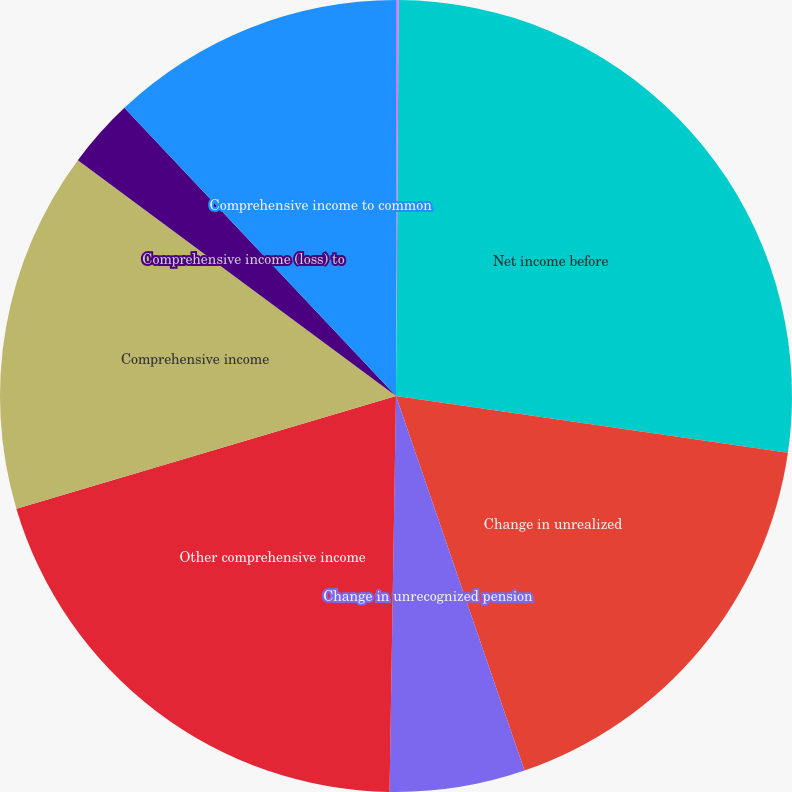Convert chart to OTSL. <chart><loc_0><loc_0><loc_500><loc_500><pie_chart><fcel>(In thousands)<fcel>Net income before<fcel>Change in unrealized<fcel>Change in unrecognized pension<fcel>Other comprehensive income<fcel>Comprehensive income<fcel>Comprehensive income (loss) to<fcel>Comprehensive income to common<nl><fcel>0.11%<fcel>27.18%<fcel>17.45%<fcel>5.52%<fcel>20.15%<fcel>14.74%<fcel>2.82%<fcel>12.03%<nl></chart> 